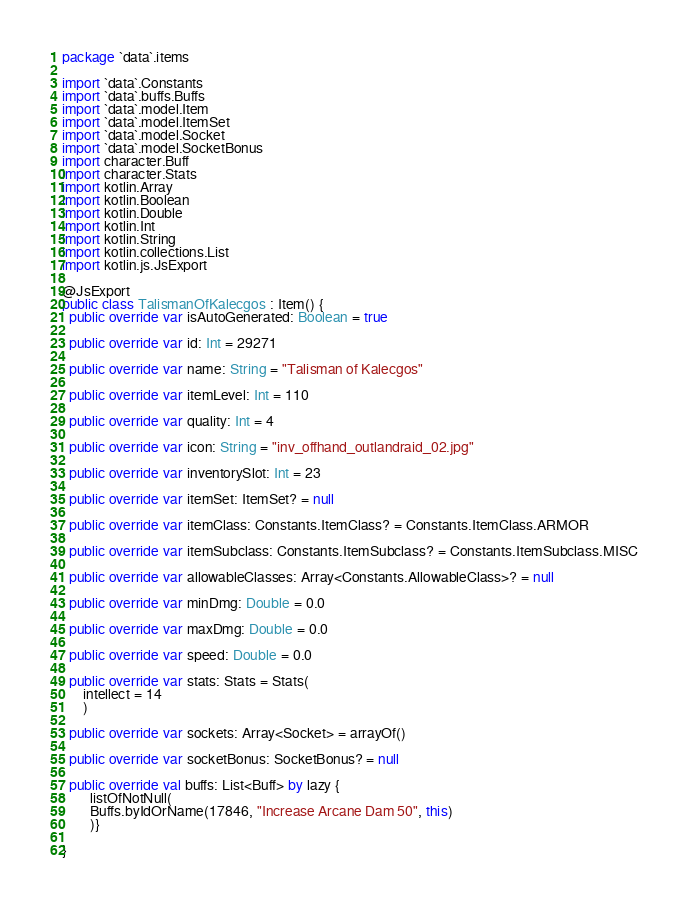<code> <loc_0><loc_0><loc_500><loc_500><_Kotlin_>package `data`.items

import `data`.Constants
import `data`.buffs.Buffs
import `data`.model.Item
import `data`.model.ItemSet
import `data`.model.Socket
import `data`.model.SocketBonus
import character.Buff
import character.Stats
import kotlin.Array
import kotlin.Boolean
import kotlin.Double
import kotlin.Int
import kotlin.String
import kotlin.collections.List
import kotlin.js.JsExport

@JsExport
public class TalismanOfKalecgos : Item() {
  public override var isAutoGenerated: Boolean = true

  public override var id: Int = 29271

  public override var name: String = "Talisman of Kalecgos"

  public override var itemLevel: Int = 110

  public override var quality: Int = 4

  public override var icon: String = "inv_offhand_outlandraid_02.jpg"

  public override var inventorySlot: Int = 23

  public override var itemSet: ItemSet? = null

  public override var itemClass: Constants.ItemClass? = Constants.ItemClass.ARMOR

  public override var itemSubclass: Constants.ItemSubclass? = Constants.ItemSubclass.MISC

  public override var allowableClasses: Array<Constants.AllowableClass>? = null

  public override var minDmg: Double = 0.0

  public override var maxDmg: Double = 0.0

  public override var speed: Double = 0.0

  public override var stats: Stats = Stats(
      intellect = 14
      )

  public override var sockets: Array<Socket> = arrayOf()

  public override var socketBonus: SocketBonus? = null

  public override val buffs: List<Buff> by lazy {
        listOfNotNull(
        Buffs.byIdOrName(17846, "Increase Arcane Dam 50", this)
        )}

}
</code> 